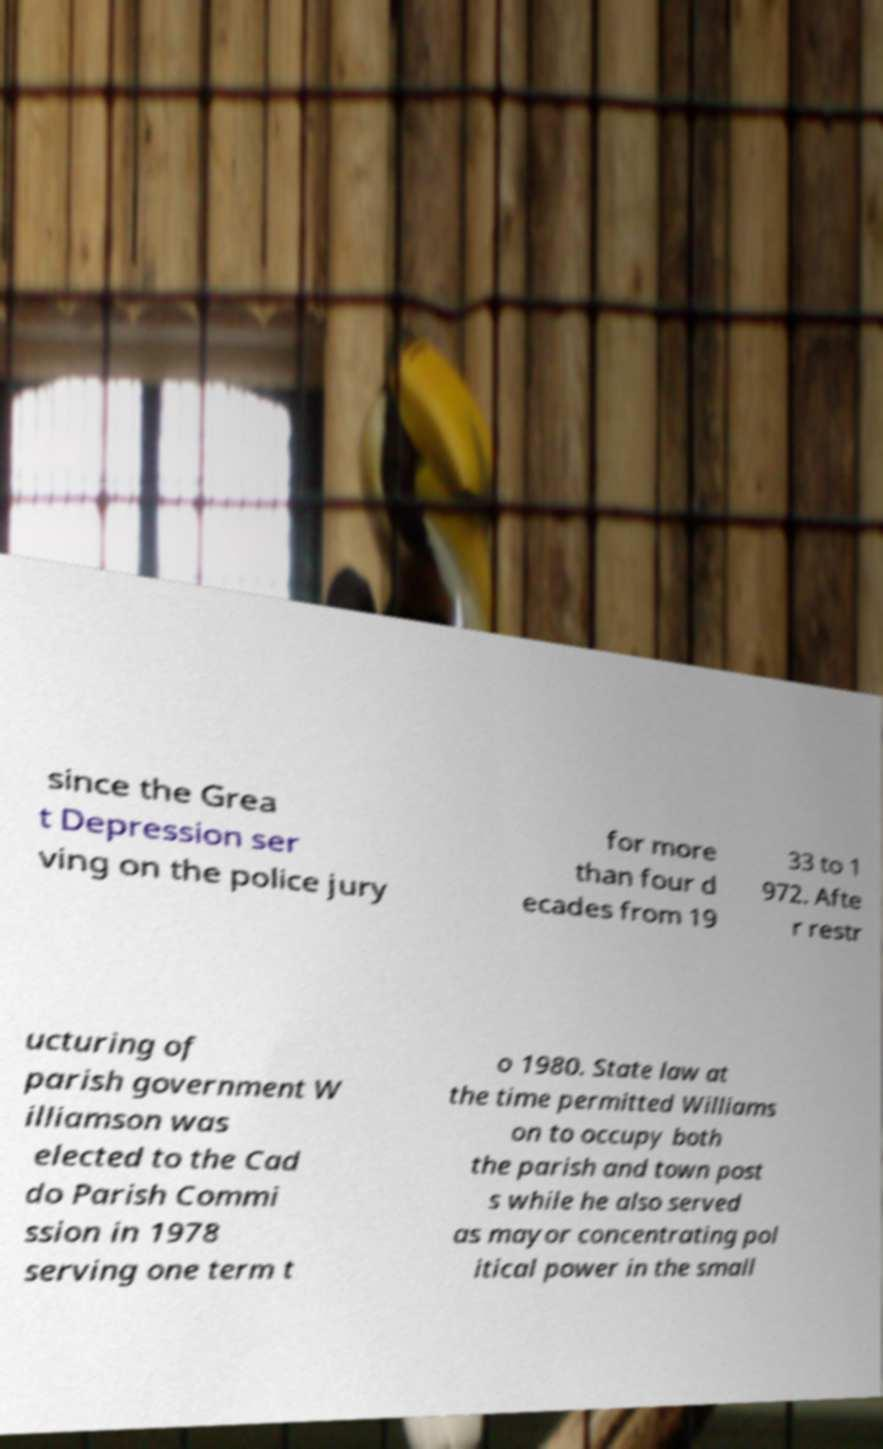What messages or text are displayed in this image? I need them in a readable, typed format. since the Grea t Depression ser ving on the police jury for more than four d ecades from 19 33 to 1 972. Afte r restr ucturing of parish government W illiamson was elected to the Cad do Parish Commi ssion in 1978 serving one term t o 1980. State law at the time permitted Williams on to occupy both the parish and town post s while he also served as mayor concentrating pol itical power in the small 